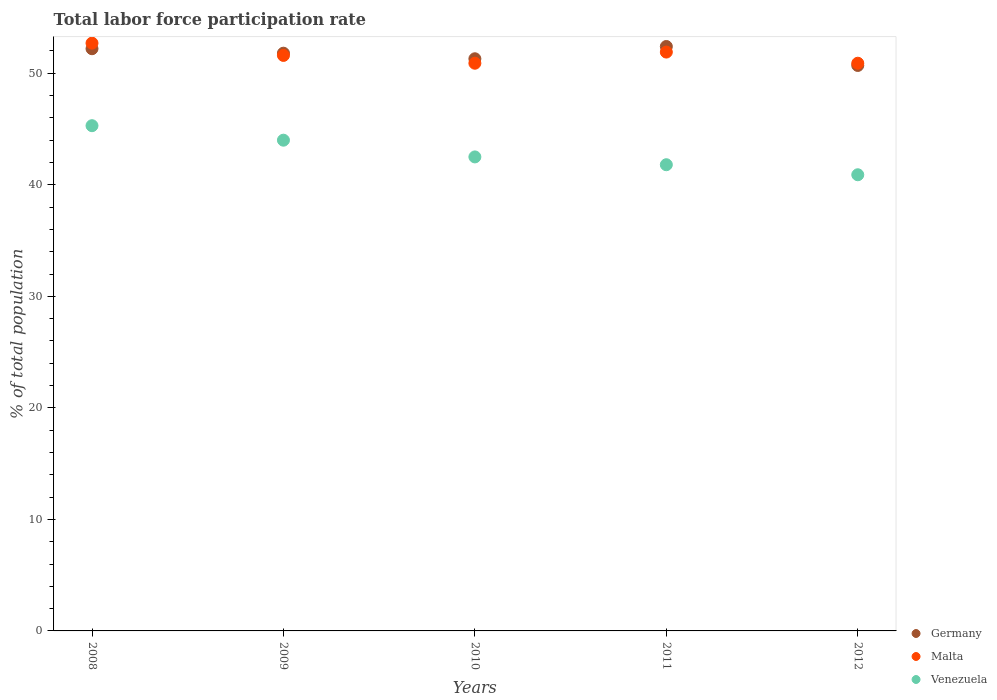What is the total labor force participation rate in Venezuela in 2011?
Give a very brief answer. 41.8. Across all years, what is the maximum total labor force participation rate in Germany?
Provide a succinct answer. 52.4. Across all years, what is the minimum total labor force participation rate in Venezuela?
Your answer should be very brief. 40.9. In which year was the total labor force participation rate in Malta minimum?
Offer a terse response. 2010. What is the total total labor force participation rate in Germany in the graph?
Provide a short and direct response. 258.4. What is the difference between the total labor force participation rate in Venezuela in 2008 and that in 2010?
Your answer should be very brief. 2.8. What is the average total labor force participation rate in Malta per year?
Provide a succinct answer. 51.6. In the year 2009, what is the difference between the total labor force participation rate in Malta and total labor force participation rate in Venezuela?
Give a very brief answer. 7.6. In how many years, is the total labor force participation rate in Germany greater than 50 %?
Provide a succinct answer. 5. What is the ratio of the total labor force participation rate in Germany in 2010 to that in 2012?
Offer a terse response. 1.01. Is the difference between the total labor force participation rate in Malta in 2010 and 2012 greater than the difference between the total labor force participation rate in Venezuela in 2010 and 2012?
Provide a succinct answer. No. What is the difference between the highest and the second highest total labor force participation rate in Malta?
Offer a terse response. 0.8. What is the difference between the highest and the lowest total labor force participation rate in Venezuela?
Your answer should be very brief. 4.4. In how many years, is the total labor force participation rate in Malta greater than the average total labor force participation rate in Malta taken over all years?
Your answer should be very brief. 2. Is the sum of the total labor force participation rate in Malta in 2011 and 2012 greater than the maximum total labor force participation rate in Venezuela across all years?
Your answer should be very brief. Yes. Is it the case that in every year, the sum of the total labor force participation rate in Germany and total labor force participation rate in Malta  is greater than the total labor force participation rate in Venezuela?
Offer a very short reply. Yes. Does the total labor force participation rate in Malta monotonically increase over the years?
Provide a succinct answer. No. What is the difference between two consecutive major ticks on the Y-axis?
Your answer should be compact. 10. Does the graph contain any zero values?
Provide a short and direct response. No. What is the title of the graph?
Your answer should be compact. Total labor force participation rate. Does "Cameroon" appear as one of the legend labels in the graph?
Give a very brief answer. No. What is the label or title of the Y-axis?
Offer a terse response. % of total population. What is the % of total population in Germany in 2008?
Your answer should be compact. 52.2. What is the % of total population of Malta in 2008?
Offer a very short reply. 52.7. What is the % of total population in Venezuela in 2008?
Give a very brief answer. 45.3. What is the % of total population in Germany in 2009?
Keep it short and to the point. 51.8. What is the % of total population of Malta in 2009?
Offer a terse response. 51.6. What is the % of total population in Venezuela in 2009?
Your answer should be compact. 44. What is the % of total population of Germany in 2010?
Your answer should be very brief. 51.3. What is the % of total population in Malta in 2010?
Provide a short and direct response. 50.9. What is the % of total population of Venezuela in 2010?
Make the answer very short. 42.5. What is the % of total population of Germany in 2011?
Ensure brevity in your answer.  52.4. What is the % of total population of Malta in 2011?
Your answer should be compact. 51.9. What is the % of total population in Venezuela in 2011?
Provide a succinct answer. 41.8. What is the % of total population in Germany in 2012?
Provide a short and direct response. 50.7. What is the % of total population of Malta in 2012?
Provide a short and direct response. 50.9. What is the % of total population in Venezuela in 2012?
Your response must be concise. 40.9. Across all years, what is the maximum % of total population of Germany?
Your answer should be compact. 52.4. Across all years, what is the maximum % of total population in Malta?
Provide a short and direct response. 52.7. Across all years, what is the maximum % of total population in Venezuela?
Your answer should be compact. 45.3. Across all years, what is the minimum % of total population of Germany?
Your response must be concise. 50.7. Across all years, what is the minimum % of total population of Malta?
Your answer should be very brief. 50.9. Across all years, what is the minimum % of total population of Venezuela?
Make the answer very short. 40.9. What is the total % of total population in Germany in the graph?
Give a very brief answer. 258.4. What is the total % of total population in Malta in the graph?
Ensure brevity in your answer.  258. What is the total % of total population in Venezuela in the graph?
Give a very brief answer. 214.5. What is the difference between the % of total population in Malta in 2008 and that in 2009?
Give a very brief answer. 1.1. What is the difference between the % of total population of Venezuela in 2008 and that in 2009?
Offer a terse response. 1.3. What is the difference between the % of total population of Germany in 2008 and that in 2011?
Your answer should be very brief. -0.2. What is the difference between the % of total population in Germany in 2008 and that in 2012?
Give a very brief answer. 1.5. What is the difference between the % of total population of Malta in 2008 and that in 2012?
Provide a succinct answer. 1.8. What is the difference between the % of total population in Venezuela in 2008 and that in 2012?
Your answer should be very brief. 4.4. What is the difference between the % of total population of Germany in 2009 and that in 2010?
Your response must be concise. 0.5. What is the difference between the % of total population in Venezuela in 2009 and that in 2010?
Your answer should be very brief. 1.5. What is the difference between the % of total population of Malta in 2009 and that in 2011?
Keep it short and to the point. -0.3. What is the difference between the % of total population of Malta in 2009 and that in 2012?
Give a very brief answer. 0.7. What is the difference between the % of total population in Venezuela in 2009 and that in 2012?
Provide a succinct answer. 3.1. What is the difference between the % of total population in Malta in 2010 and that in 2011?
Offer a terse response. -1. What is the difference between the % of total population of Venezuela in 2010 and that in 2011?
Provide a short and direct response. 0.7. What is the difference between the % of total population of Malta in 2010 and that in 2012?
Your response must be concise. 0. What is the difference between the % of total population of Venezuela in 2010 and that in 2012?
Ensure brevity in your answer.  1.6. What is the difference between the % of total population in Venezuela in 2011 and that in 2012?
Your response must be concise. 0.9. What is the difference between the % of total population of Germany in 2008 and the % of total population of Malta in 2009?
Keep it short and to the point. 0.6. What is the difference between the % of total population in Germany in 2008 and the % of total population in Venezuela in 2009?
Your answer should be very brief. 8.2. What is the difference between the % of total population in Germany in 2008 and the % of total population in Venezuela in 2011?
Ensure brevity in your answer.  10.4. What is the difference between the % of total population in Malta in 2008 and the % of total population in Venezuela in 2011?
Make the answer very short. 10.9. What is the difference between the % of total population in Malta in 2009 and the % of total population in Venezuela in 2010?
Provide a succinct answer. 9.1. What is the difference between the % of total population of Germany in 2009 and the % of total population of Venezuela in 2011?
Provide a succinct answer. 10. What is the difference between the % of total population in Germany in 2009 and the % of total population in Venezuela in 2012?
Offer a very short reply. 10.9. What is the difference between the % of total population in Malta in 2009 and the % of total population in Venezuela in 2012?
Offer a terse response. 10.7. What is the difference between the % of total population in Germany in 2010 and the % of total population in Malta in 2012?
Offer a very short reply. 0.4. What is the difference between the % of total population of Germany in 2011 and the % of total population of Venezuela in 2012?
Provide a short and direct response. 11.5. What is the difference between the % of total population in Malta in 2011 and the % of total population in Venezuela in 2012?
Offer a very short reply. 11. What is the average % of total population in Germany per year?
Offer a very short reply. 51.68. What is the average % of total population of Malta per year?
Offer a terse response. 51.6. What is the average % of total population of Venezuela per year?
Your response must be concise. 42.9. In the year 2008, what is the difference between the % of total population of Germany and % of total population of Malta?
Offer a terse response. -0.5. In the year 2008, what is the difference between the % of total population in Germany and % of total population in Venezuela?
Keep it short and to the point. 6.9. In the year 2008, what is the difference between the % of total population of Malta and % of total population of Venezuela?
Your response must be concise. 7.4. In the year 2009, what is the difference between the % of total population of Germany and % of total population of Malta?
Provide a succinct answer. 0.2. In the year 2009, what is the difference between the % of total population of Germany and % of total population of Venezuela?
Your response must be concise. 7.8. In the year 2009, what is the difference between the % of total population in Malta and % of total population in Venezuela?
Provide a succinct answer. 7.6. In the year 2010, what is the difference between the % of total population of Germany and % of total population of Malta?
Your answer should be compact. 0.4. In the year 2010, what is the difference between the % of total population in Germany and % of total population in Venezuela?
Keep it short and to the point. 8.8. In the year 2011, what is the difference between the % of total population in Germany and % of total population in Malta?
Your answer should be compact. 0.5. In the year 2012, what is the difference between the % of total population of Germany and % of total population of Venezuela?
Offer a terse response. 9.8. What is the ratio of the % of total population of Germany in 2008 to that in 2009?
Offer a very short reply. 1.01. What is the ratio of the % of total population in Malta in 2008 to that in 2009?
Make the answer very short. 1.02. What is the ratio of the % of total population in Venezuela in 2008 to that in 2009?
Make the answer very short. 1.03. What is the ratio of the % of total population of Germany in 2008 to that in 2010?
Offer a terse response. 1.02. What is the ratio of the % of total population in Malta in 2008 to that in 2010?
Make the answer very short. 1.04. What is the ratio of the % of total population of Venezuela in 2008 to that in 2010?
Your response must be concise. 1.07. What is the ratio of the % of total population of Malta in 2008 to that in 2011?
Offer a terse response. 1.02. What is the ratio of the % of total population of Venezuela in 2008 to that in 2011?
Your answer should be very brief. 1.08. What is the ratio of the % of total population in Germany in 2008 to that in 2012?
Offer a very short reply. 1.03. What is the ratio of the % of total population in Malta in 2008 to that in 2012?
Ensure brevity in your answer.  1.04. What is the ratio of the % of total population of Venezuela in 2008 to that in 2012?
Make the answer very short. 1.11. What is the ratio of the % of total population of Germany in 2009 to that in 2010?
Your response must be concise. 1.01. What is the ratio of the % of total population of Malta in 2009 to that in 2010?
Make the answer very short. 1.01. What is the ratio of the % of total population in Venezuela in 2009 to that in 2010?
Offer a very short reply. 1.04. What is the ratio of the % of total population of Malta in 2009 to that in 2011?
Offer a very short reply. 0.99. What is the ratio of the % of total population in Venezuela in 2009 to that in 2011?
Ensure brevity in your answer.  1.05. What is the ratio of the % of total population of Germany in 2009 to that in 2012?
Make the answer very short. 1.02. What is the ratio of the % of total population of Malta in 2009 to that in 2012?
Provide a short and direct response. 1.01. What is the ratio of the % of total population of Venezuela in 2009 to that in 2012?
Make the answer very short. 1.08. What is the ratio of the % of total population in Germany in 2010 to that in 2011?
Offer a terse response. 0.98. What is the ratio of the % of total population of Malta in 2010 to that in 2011?
Your response must be concise. 0.98. What is the ratio of the % of total population of Venezuela in 2010 to that in 2011?
Provide a succinct answer. 1.02. What is the ratio of the % of total population of Germany in 2010 to that in 2012?
Offer a terse response. 1.01. What is the ratio of the % of total population in Malta in 2010 to that in 2012?
Your answer should be compact. 1. What is the ratio of the % of total population of Venezuela in 2010 to that in 2012?
Make the answer very short. 1.04. What is the ratio of the % of total population in Germany in 2011 to that in 2012?
Make the answer very short. 1.03. What is the ratio of the % of total population of Malta in 2011 to that in 2012?
Ensure brevity in your answer.  1.02. What is the ratio of the % of total population in Venezuela in 2011 to that in 2012?
Your answer should be compact. 1.02. What is the difference between the highest and the second highest % of total population in Malta?
Offer a terse response. 0.8. What is the difference between the highest and the lowest % of total population in Germany?
Offer a very short reply. 1.7. What is the difference between the highest and the lowest % of total population in Malta?
Provide a succinct answer. 1.8. What is the difference between the highest and the lowest % of total population of Venezuela?
Keep it short and to the point. 4.4. 